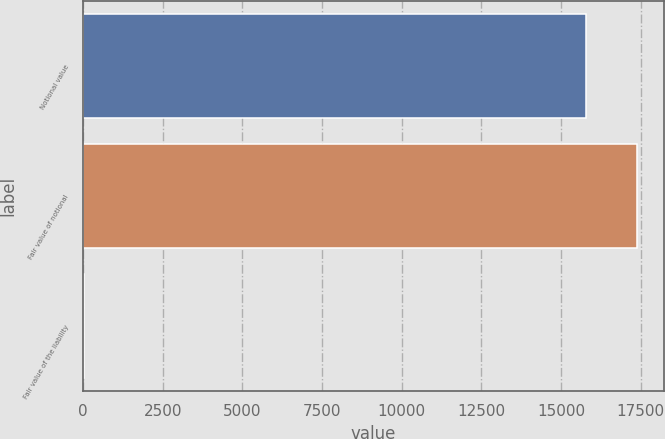Convert chart. <chart><loc_0><loc_0><loc_500><loc_500><bar_chart><fcel>Notional value<fcel>Fair value of notional<fcel>Fair value of the liability<nl><fcel>15792<fcel>17371.2<fcel>17<nl></chart> 